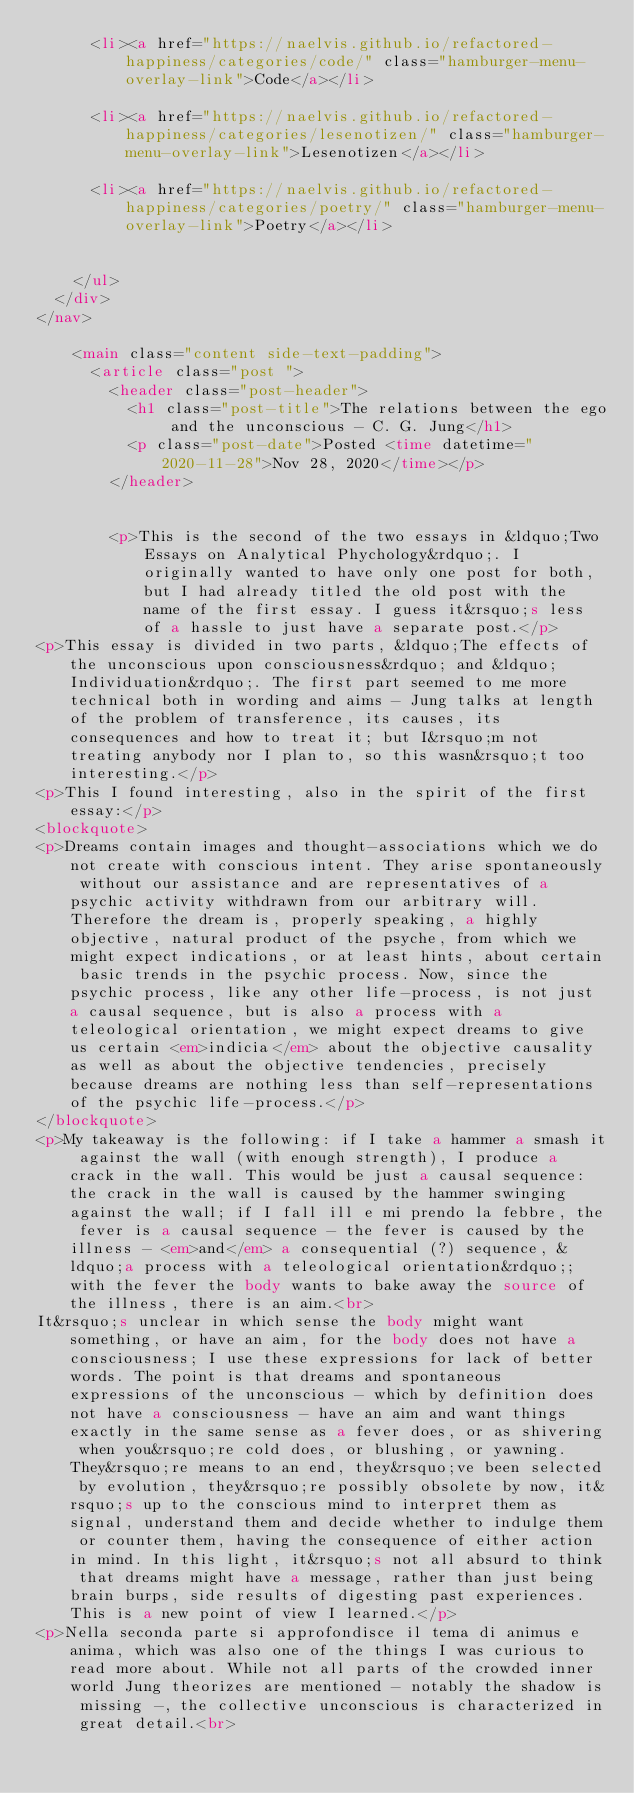Convert code to text. <code><loc_0><loc_0><loc_500><loc_500><_HTML_>      <li><a href="https://naelvis.github.io/refactored-happiness/categories/code/" class="hamburger-menu-overlay-link">Code</a></li>
      
      <li><a href="https://naelvis.github.io/refactored-happiness/categories/lesenotizen/" class="hamburger-menu-overlay-link">Lesenotizen</a></li>
      
      <li><a href="https://naelvis.github.io/refactored-happiness/categories/poetry/" class="hamburger-menu-overlay-link">Poetry</a></li>
      
      
    </ul>
  </div>
</nav>

    <main class="content side-text-padding">
      <article class="post ">
        <header class="post-header">
          <h1 class="post-title">The relations between the ego and the unconscious - C. G. Jung</h1>
          <p class="post-date">Posted <time datetime="2020-11-28">Nov 28, 2020</time></p>
        </header>
        
        
        <p>This is the second of the two essays in &ldquo;Two Essays on Analytical Phychology&rdquo;. I originally wanted to have only one post for both, but I had already titled the old post with the name of the first essay. I guess it&rsquo;s less of a hassle to just have a separate post.</p>
<p>This essay is divided in two parts, &ldquo;The effects of the unconscious upon consciousness&rdquo; and &ldquo;Individuation&rdquo;. The first part seemed to me more technical both in wording and aims - Jung talks at length of the problem of transference, its causes, its consequences and how to treat it; but I&rsquo;m not treating anybody nor I plan to, so this wasn&rsquo;t too interesting.</p>
<p>This I found interesting, also in the spirit of the first essay:</p>
<blockquote>
<p>Dreams contain images and thought-associations which we do not create with conscious intent. They arise spontaneously without our assistance and are representatives of a psychic activity withdrawn from our arbitrary will. Therefore the dream is, properly speaking, a highly objective, natural product of the psyche, from which we might expect indications, or at least hints, about certain basic trends in the psychic process. Now, since the psychic process, like any other life-process, is not just a causal sequence, but is also a process with a teleological orientation, we might expect dreams to give us certain <em>indicia</em> about the objective causality as well as about the objective tendencies, precisely because dreams are nothing less than self-representations of the psychic life-process.</p>
</blockquote>
<p>My takeaway is the following: if I take a hammer a smash it against the wall (with enough strength), I produce a crack in the wall. This would be just a causal sequence: the crack in the wall is caused by the hammer swinging against the wall; if I fall ill e mi prendo la febbre, the fever is a causal sequence - the fever is caused by the illness - <em>and</em> a consequential (?) sequence, &ldquo;a process with a teleological orientation&rdquo;; with the fever the body wants to bake away the source of the illness, there is an aim.<br>
It&rsquo;s unclear in which sense the body might want something, or have an aim, for the body does not have a consciousness; I use these expressions for lack of better words. The point is that dreams and spontaneous expressions of the unconscious - which by definition does not have a consciousness - have an aim and want things exactly in the same sense as a fever does, or as shivering when you&rsquo;re cold does, or blushing, or yawning. They&rsquo;re means to an end, they&rsquo;ve been selected by evolution, they&rsquo;re possibly obsolete by now, it&rsquo;s up to the conscious mind to interpret them as signal, understand them and decide whether to indulge them or counter them, having the consequence of either action in mind. In this light, it&rsquo;s not all absurd to think that dreams might have a message, rather than just being brain burps, side results of digesting past experiences. This is a new point of view I learned.</p>
<p>Nella seconda parte si approfondisce il tema di animus e anima, which was also one of the things I was curious to read more about. While not all parts of the crowded inner world Jung theorizes are mentioned - notably the shadow is missing -, the collective unconscious is characterized in great detail.<br></code> 